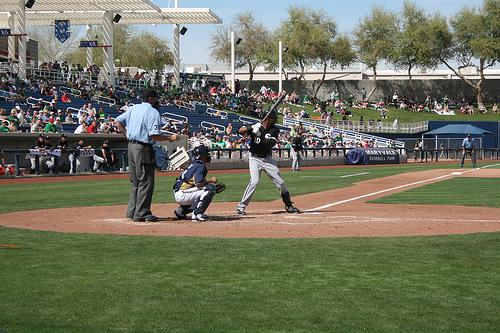Question: when was this picture taken?
Choices:
A. During a concert.
B. During a baseball game.
C. During a volleyball game.
D. During a round of golf.
Answer with the letter. Answer: B Question: where was the photo taken?
Choices:
A. Volleyball court.
B. Baseball field.
C. Basketball court.
D. In a theater.
Answer with the letter. Answer: B Question: what is out there in the distance?
Choices:
A. Trees.
B. Mountains.
C. A lake.
D. Stars.
Answer with the letter. Answer: A Question: who is up to bat?
Choices:
A. The businessman.
B. The old woman.
C. The batter.
D. The boy.
Answer with the letter. Answer: C Question: what are these guys doing?
Choices:
A. Fishing.
B. Talking.
C. Playing soccer.
D. Playing baseball.
Answer with the letter. Answer: D Question: what is this guy getting ready to do?
Choices:
A. Call balls and strikes.
B. Mow the grass.
C. Hit the ball.
D. Go for a walk.
Answer with the letter. Answer: C Question: how many people are out there in the field?
Choices:
A. 5.
B. 3.
C. 4.
D. 2 players.
Answer with the letter. Answer: D 